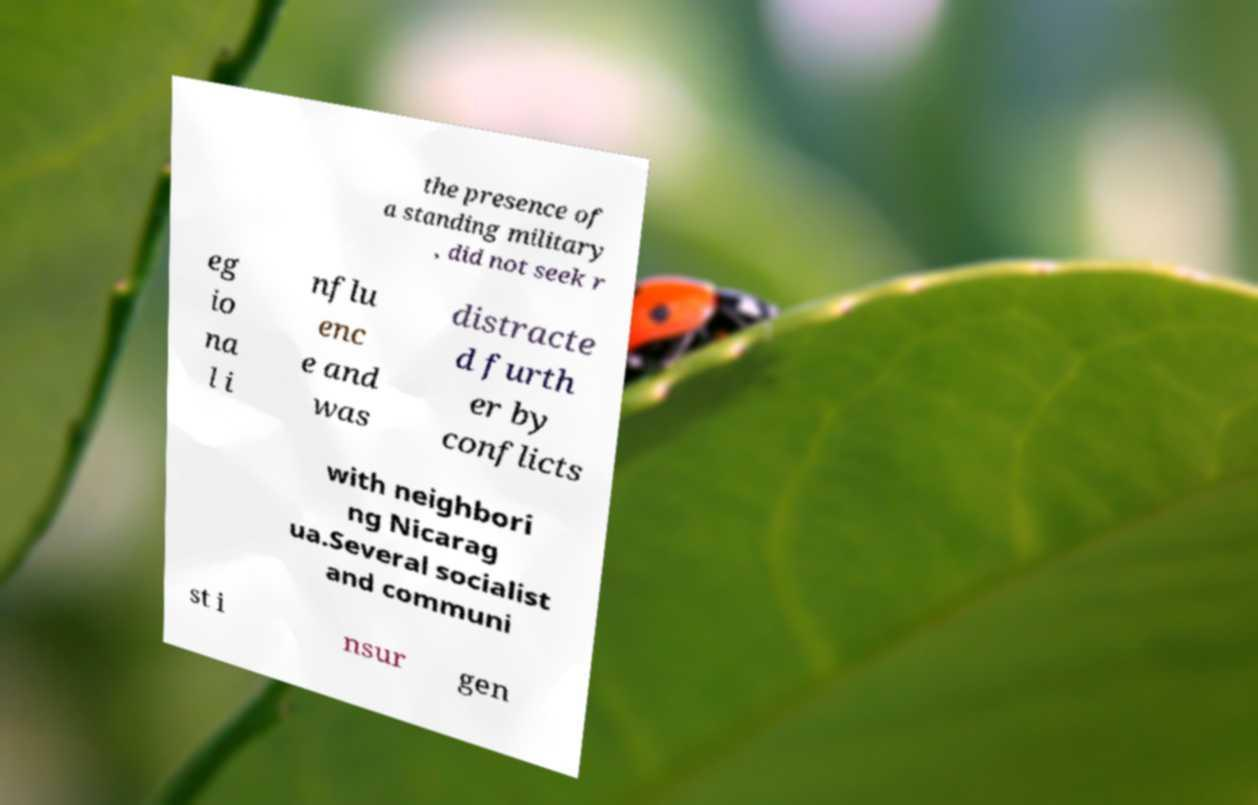Please read and relay the text visible in this image. What does it say? the presence of a standing military , did not seek r eg io na l i nflu enc e and was distracte d furth er by conflicts with neighbori ng Nicarag ua.Several socialist and communi st i nsur gen 